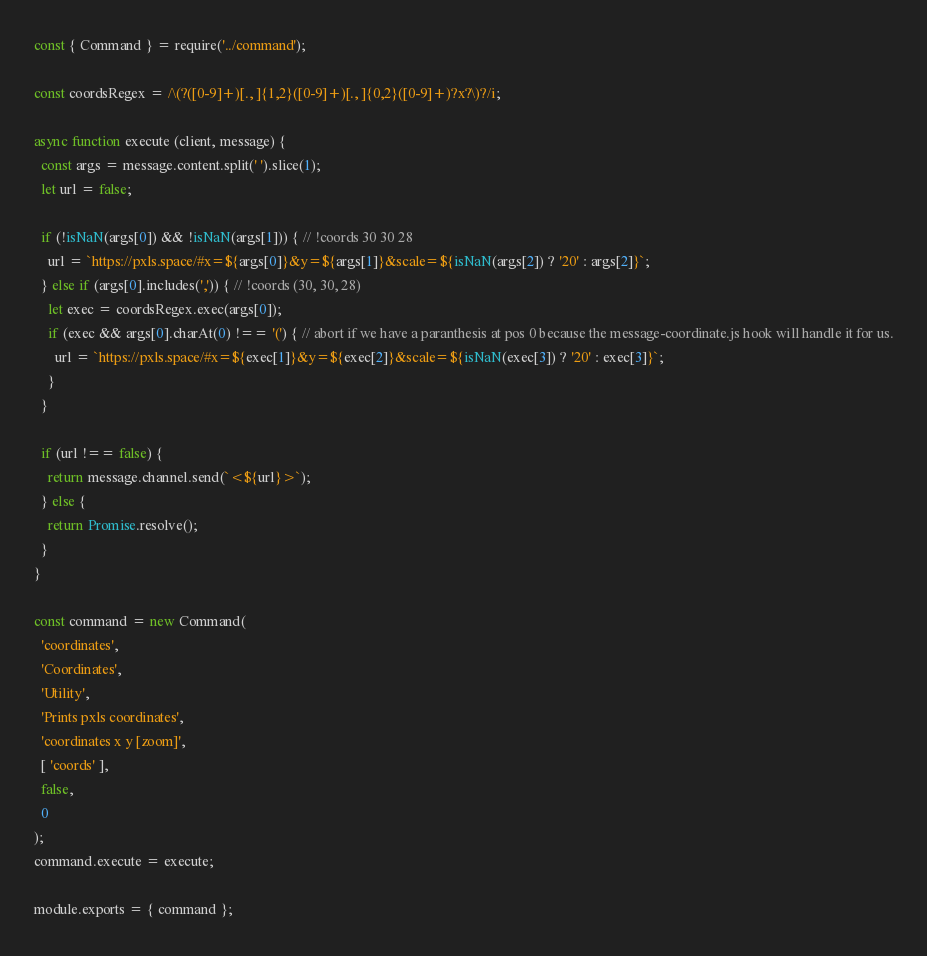<code> <loc_0><loc_0><loc_500><loc_500><_JavaScript_>const { Command } = require('../command');

const coordsRegex = /\(?([0-9]+)[., ]{1,2}([0-9]+)[., ]{0,2}([0-9]+)?x?\)?/i;

async function execute (client, message) {
  const args = message.content.split(' ').slice(1);
  let url = false;

  if (!isNaN(args[0]) && !isNaN(args[1])) { // !coords 30 30 28
    url = `https://pxls.space/#x=${args[0]}&y=${args[1]}&scale=${isNaN(args[2]) ? '20' : args[2]}`;
  } else if (args[0].includes(',')) { // !coords (30, 30, 28)
    let exec = coordsRegex.exec(args[0]);
    if (exec && args[0].charAt(0) !== '(') { // abort if we have a paranthesis at pos 0 because the message-coordinate.js hook will handle it for us.
      url = `https://pxls.space/#x=${exec[1]}&y=${exec[2]}&scale=${isNaN(exec[3]) ? '20' : exec[3]}`;
    }
  }

  if (url !== false) {
    return message.channel.send(`<${url}>`);
  } else {
    return Promise.resolve();
  }
}

const command = new Command(
  'coordinates',
  'Coordinates',
  'Utility',
  'Prints pxls coordinates',
  'coordinates x y [zoom]',
  [ 'coords' ],
  false,
  0
);
command.execute = execute;

module.exports = { command };
</code> 